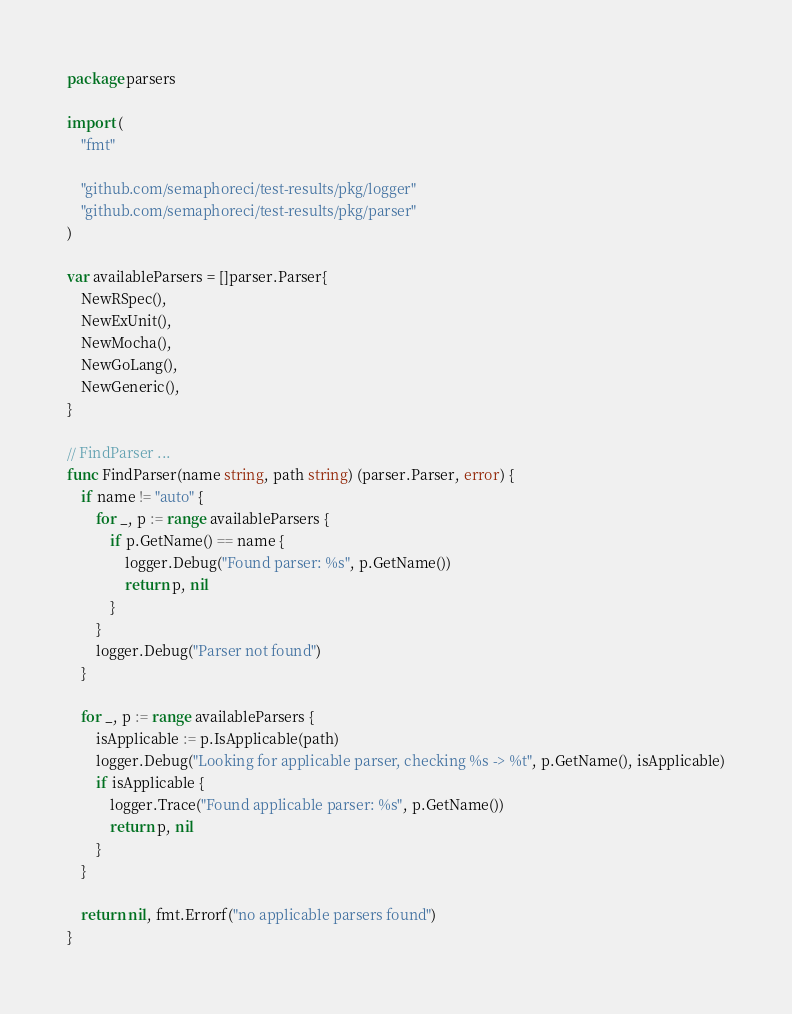Convert code to text. <code><loc_0><loc_0><loc_500><loc_500><_Go_>package parsers

import (
	"fmt"

	"github.com/semaphoreci/test-results/pkg/logger"
	"github.com/semaphoreci/test-results/pkg/parser"
)

var availableParsers = []parser.Parser{
	NewRSpec(),
	NewExUnit(),
	NewMocha(),
	NewGoLang(),
	NewGeneric(),
}

// FindParser ...
func FindParser(name string, path string) (parser.Parser, error) {
	if name != "auto" {
		for _, p := range availableParsers {
			if p.GetName() == name {
				logger.Debug("Found parser: %s", p.GetName())
				return p, nil
			}
		}
		logger.Debug("Parser not found")
	}

	for _, p := range availableParsers {
		isApplicable := p.IsApplicable(path)
		logger.Debug("Looking for applicable parser, checking %s -> %t", p.GetName(), isApplicable)
		if isApplicable {
			logger.Trace("Found applicable parser: %s", p.GetName())
			return p, nil
		}
	}

	return nil, fmt.Errorf("no applicable parsers found")
}
</code> 